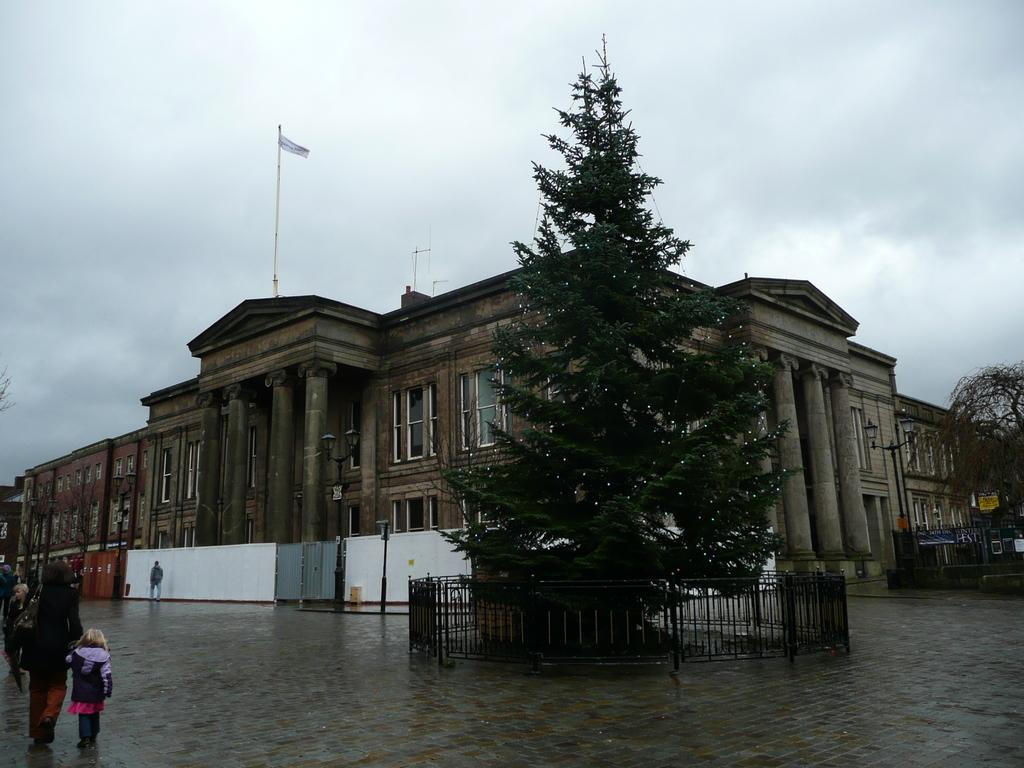Who is present in the image? There is a woman and a girl in the image. What are the woman and girl doing in the image? The woman and girl are walking together in the image. What can be seen on the right side of the image? There is a tree on the right side of the image. What is visible in the background of the image? There is a building in the background of the image. What type of cup can be seen in the girl's hand in the image? There is no cup visible in the girl's hand or anywhere else in the image. 